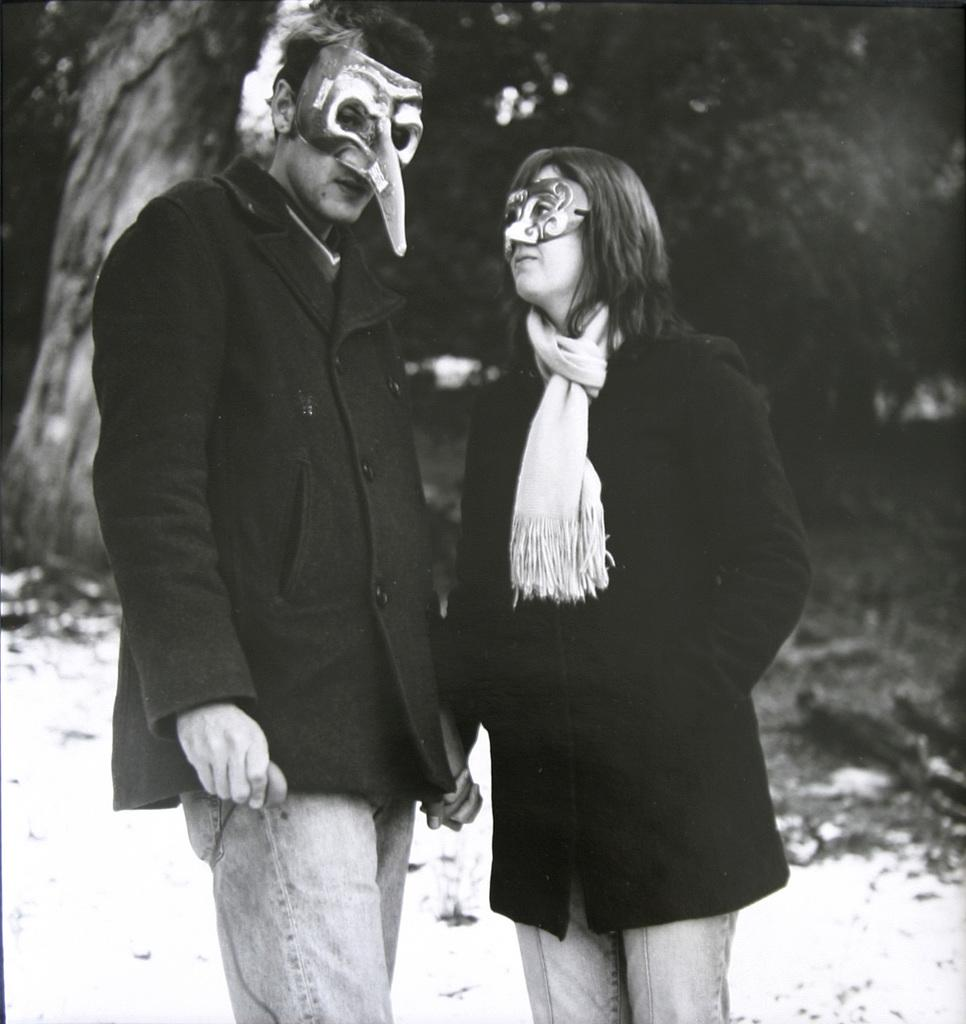How many people are in the image? There are two people in the image. What are the people doing in the image? The people are standing. What are the people wearing on their faces in the image? The people are wearing masks. What is the color scheme of the image? The image is black and white. Where is the seashore located in the image? There is no seashore present in the image; it is a black and white image of two people standing and wearing masks. What are the people's interests in the image? The image does not provide information about the people's interests; it only shows them standing and wearing masks. 